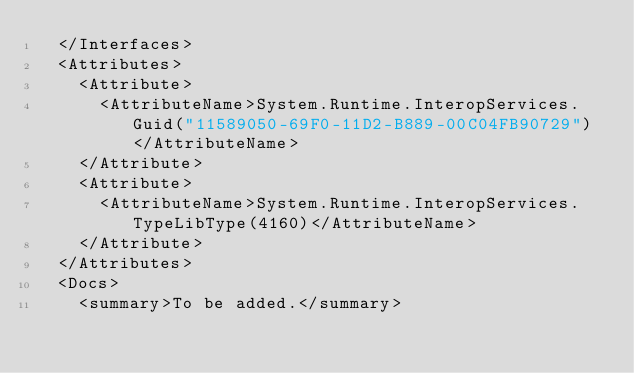<code> <loc_0><loc_0><loc_500><loc_500><_XML_>  </Interfaces>
  <Attributes>
    <Attribute>
      <AttributeName>System.Runtime.InteropServices.Guid("11589050-69F0-11D2-B889-00C04FB90729")</AttributeName>
    </Attribute>
    <Attribute>
      <AttributeName>System.Runtime.InteropServices.TypeLibType(4160)</AttributeName>
    </Attribute>
  </Attributes>
  <Docs>
    <summary>To be added.</summary></code> 